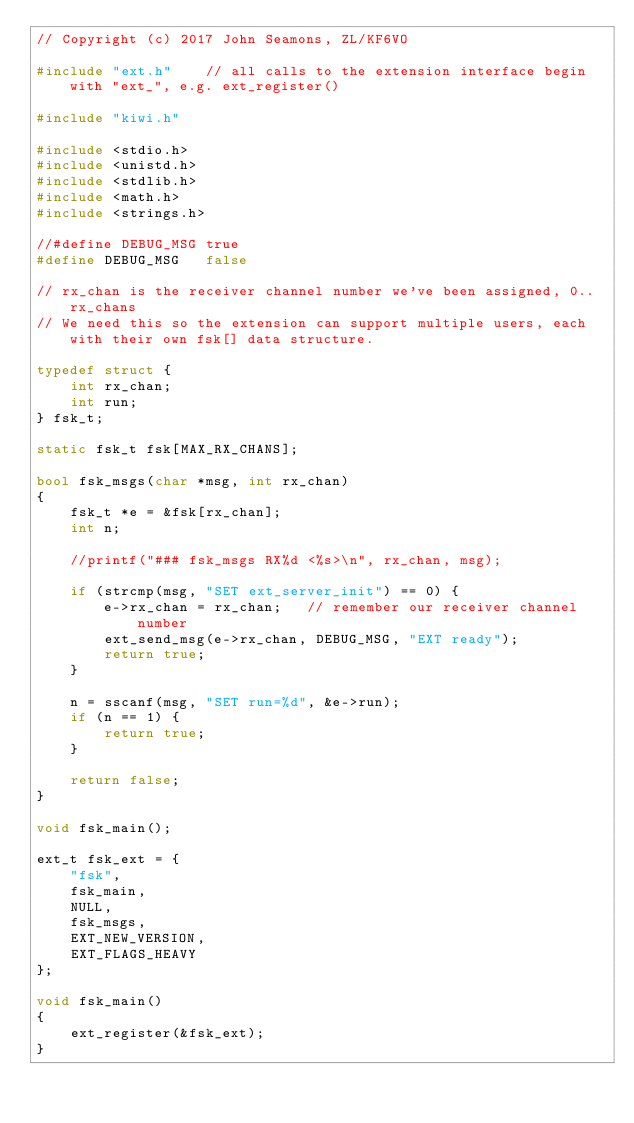Convert code to text. <code><loc_0><loc_0><loc_500><loc_500><_C++_>// Copyright (c) 2017 John Seamons, ZL/KF6VO

#include "ext.h"	// all calls to the extension interface begin with "ext_", e.g. ext_register()

#include "kiwi.h"

#include <stdio.h>
#include <unistd.h>
#include <stdlib.h>
#include <math.h>
#include <strings.h>

//#define DEBUG_MSG	true
#define DEBUG_MSG	false

// rx_chan is the receiver channel number we've been assigned, 0..rx_chans
// We need this so the extension can support multiple users, each with their own fsk[] data structure.

typedef struct {
	int rx_chan;
	int run;
} fsk_t;

static fsk_t fsk[MAX_RX_CHANS];

bool fsk_msgs(char *msg, int rx_chan)
{
	fsk_t *e = &fsk[rx_chan];
	int n;
	
	//printf("### fsk_msgs RX%d <%s>\n", rx_chan, msg);
	
	if (strcmp(msg, "SET ext_server_init") == 0) {
		e->rx_chan = rx_chan;	// remember our receiver channel number
		ext_send_msg(e->rx_chan, DEBUG_MSG, "EXT ready");
		return true;
	}

	n = sscanf(msg, "SET run=%d", &e->run);
	if (n == 1) {
		return true;
	}
	
	return false;
}

void fsk_main();

ext_t fsk_ext = {
	"fsk",
	fsk_main,
	NULL,
	fsk_msgs,
	EXT_NEW_VERSION,
	EXT_FLAGS_HEAVY
};

void fsk_main()
{
	ext_register(&fsk_ext);
}
</code> 